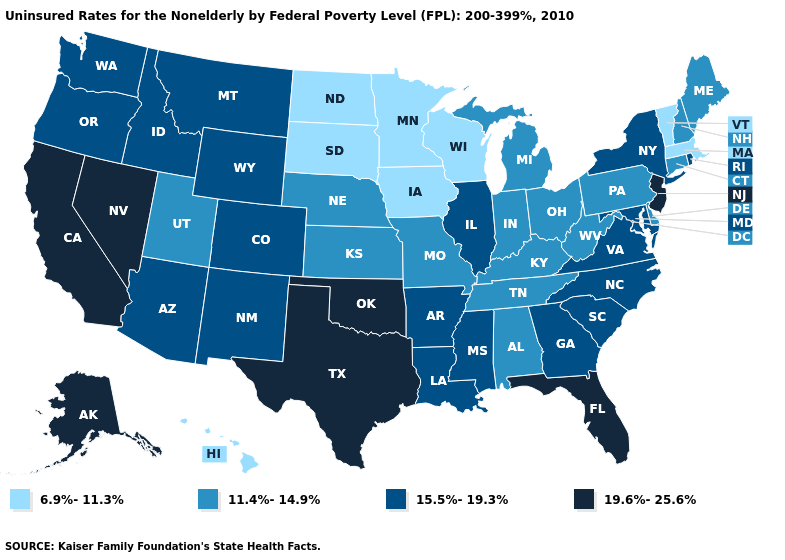What is the value of Kentucky?
Be succinct. 11.4%-14.9%. What is the lowest value in states that border North Dakota?
Quick response, please. 6.9%-11.3%. Among the states that border New Hampshire , which have the highest value?
Concise answer only. Maine. Name the states that have a value in the range 6.9%-11.3%?
Keep it brief. Hawaii, Iowa, Massachusetts, Minnesota, North Dakota, South Dakota, Vermont, Wisconsin. Name the states that have a value in the range 19.6%-25.6%?
Keep it brief. Alaska, California, Florida, Nevada, New Jersey, Oklahoma, Texas. Name the states that have a value in the range 15.5%-19.3%?
Short answer required. Arizona, Arkansas, Colorado, Georgia, Idaho, Illinois, Louisiana, Maryland, Mississippi, Montana, New Mexico, New York, North Carolina, Oregon, Rhode Island, South Carolina, Virginia, Washington, Wyoming. Does Tennessee have the lowest value in the South?
Concise answer only. Yes. Name the states that have a value in the range 11.4%-14.9%?
Keep it brief. Alabama, Connecticut, Delaware, Indiana, Kansas, Kentucky, Maine, Michigan, Missouri, Nebraska, New Hampshire, Ohio, Pennsylvania, Tennessee, Utah, West Virginia. Among the states that border Delaware , which have the lowest value?
Short answer required. Pennsylvania. Among the states that border Nebraska , does Missouri have the highest value?
Short answer required. No. Among the states that border Oregon , which have the highest value?
Write a very short answer. California, Nevada. Name the states that have a value in the range 15.5%-19.3%?
Give a very brief answer. Arizona, Arkansas, Colorado, Georgia, Idaho, Illinois, Louisiana, Maryland, Mississippi, Montana, New Mexico, New York, North Carolina, Oregon, Rhode Island, South Carolina, Virginia, Washington, Wyoming. Among the states that border Delaware , which have the highest value?
Short answer required. New Jersey. Name the states that have a value in the range 15.5%-19.3%?
Keep it brief. Arizona, Arkansas, Colorado, Georgia, Idaho, Illinois, Louisiana, Maryland, Mississippi, Montana, New Mexico, New York, North Carolina, Oregon, Rhode Island, South Carolina, Virginia, Washington, Wyoming. Does the first symbol in the legend represent the smallest category?
Write a very short answer. Yes. 